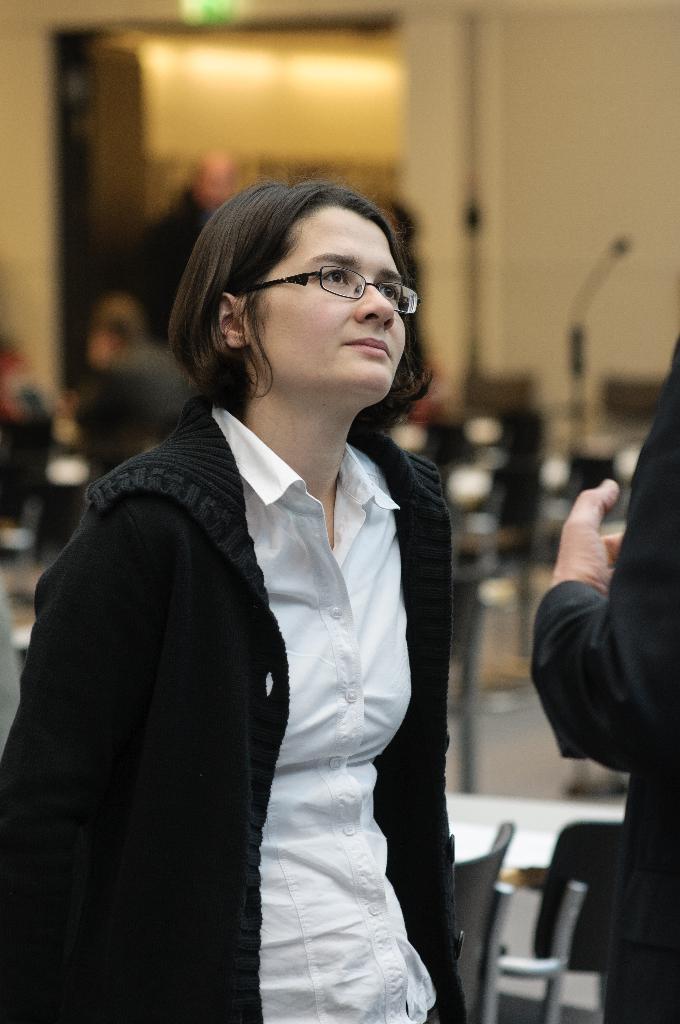In one or two sentences, can you explain what this image depicts? In this image there is a woman standing, and there is another person, and in the background there are chairs, tables, there are group of people and a door. 